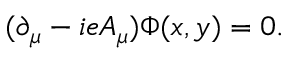Convert formula to latex. <formula><loc_0><loc_0><loc_500><loc_500>( \partial _ { \mu } - i e A _ { \mu } ) \Phi ( x , y ) = 0 .</formula> 